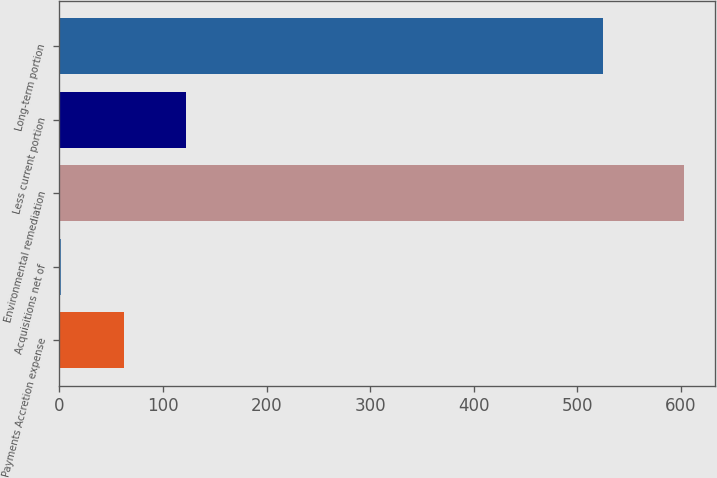Convert chart to OTSL. <chart><loc_0><loc_0><loc_500><loc_500><bar_chart><fcel>Payments Accretion expense<fcel>Acquisitions net of<fcel>Environmental remediation<fcel>Less current portion<fcel>Long-term portion<nl><fcel>61.91<fcel>1.8<fcel>602.9<fcel>122.02<fcel>525<nl></chart> 